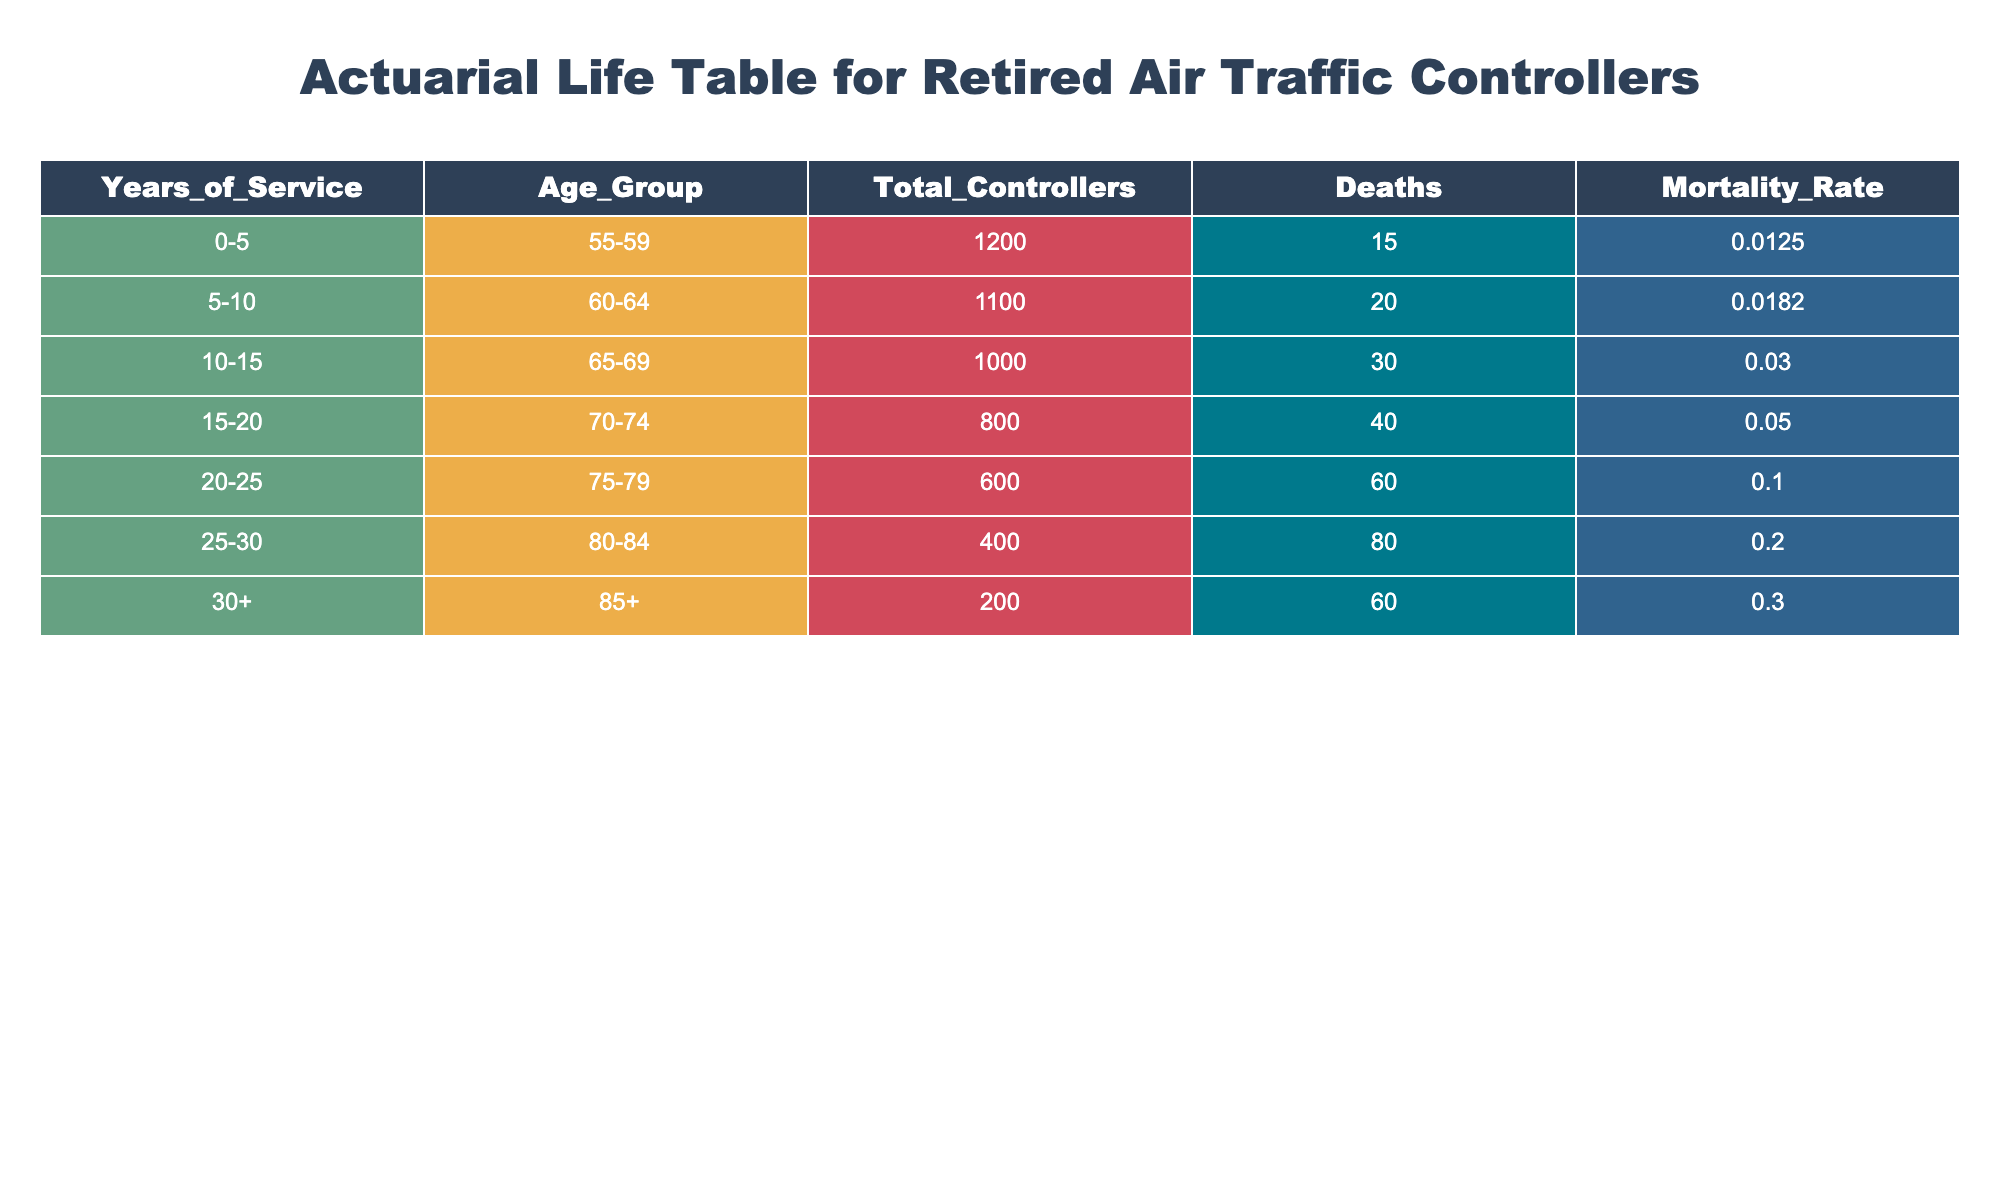What is the mortality rate for retired air traffic controllers with 20-25 years of service? The table shows that for the age group 75-79 with 20-25 years of service, the mortality rate is 0.1000.
Answer: 0.1000 How many total controllers are there in the 10-15 years of service group? The table indicates that there are 1000 total controllers in the 10-15 years of service group.
Answer: 1000 Is the mortality rate higher for the 30+ years of service group compared to the 0-5 years of service group? The mortality rate for 30+ years of service is 0.3000, while for 0-5 years it is 0.0125, making the former significantly higher.
Answer: Yes What is the total number of deaths among retired air traffic controllers with 25-30 years of service? According to the table, there are 80 deaths recorded in the 25-30 years of service group.
Answer: 80 What is the average mortality rate across all service years? To find the average, we sum the mortality rates: (0.0125 + 0.0182 + 0.0300 + 0.0500 + 0.1000 + 0.2000 + 0.3000) = 0.7107. Dividing by 7 (the number of groups), the average is approximately 0.101.
Answer: 0.101 Are there more controllers in the 20-25 years of service group than in the 15-20 years of service group? The table states there are 600 controllers in the 20-25 years of service group and 800 in the 15-20 years of service group, indicating there are fewer in the former.
Answer: No What is the total number of deaths for all controllers aged 80 and over? For the age group 80-84 with 25-30 years of service, there were 80 deaths, and for 85+, there were 60 deaths. Summing these gives: 80 + 60 = 140 deaths.
Answer: 140 How does the mortality rate change from the 5-10 years of service group to the 15-20 years of service group? The mortality rate for 5-10 years of service is 0.0182, and for 15-20 years, it is 0.0500. The increase is from 0.0182 to 0.0500, indicating a rise as service years increase.
Answer: It increases What is the difference in total controllers between the 0-5 and 25-30 years of service groups? The 0-5 years group has 1200 controllers, while the 25-30 years group has 400. The difference is 1200 - 400 = 800.
Answer: 800 